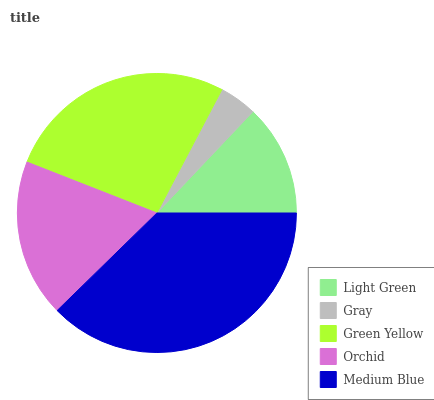Is Gray the minimum?
Answer yes or no. Yes. Is Medium Blue the maximum?
Answer yes or no. Yes. Is Green Yellow the minimum?
Answer yes or no. No. Is Green Yellow the maximum?
Answer yes or no. No. Is Green Yellow greater than Gray?
Answer yes or no. Yes. Is Gray less than Green Yellow?
Answer yes or no. Yes. Is Gray greater than Green Yellow?
Answer yes or no. No. Is Green Yellow less than Gray?
Answer yes or no. No. Is Orchid the high median?
Answer yes or no. Yes. Is Orchid the low median?
Answer yes or no. Yes. Is Gray the high median?
Answer yes or no. No. Is Medium Blue the low median?
Answer yes or no. No. 